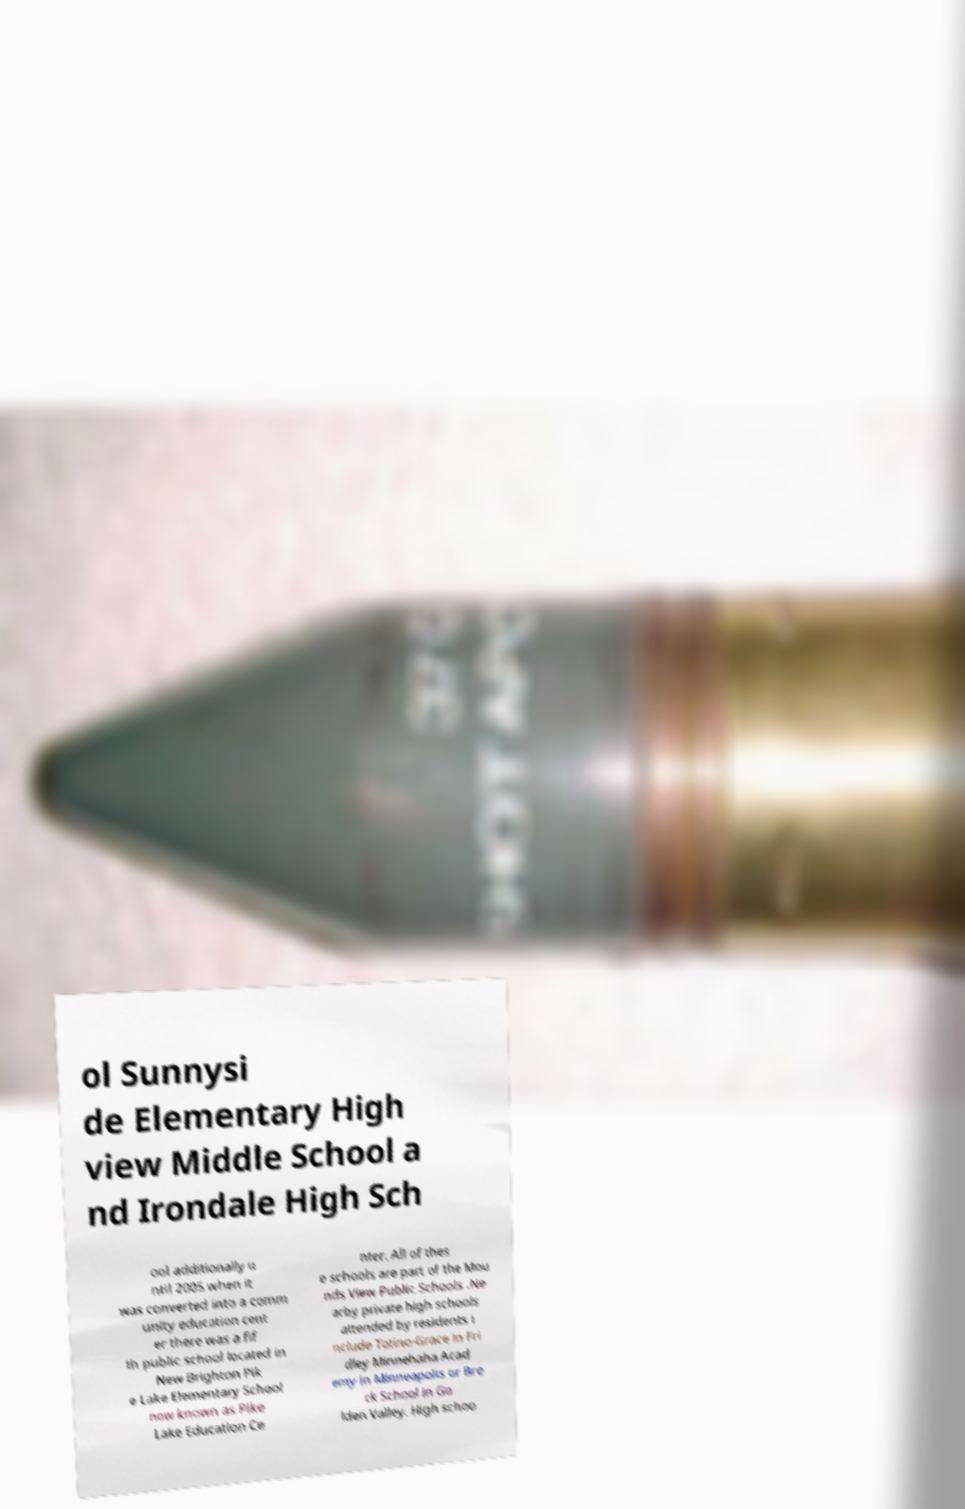Could you extract and type out the text from this image? ol Sunnysi de Elementary High view Middle School a nd Irondale High Sch ool additionally u ntil 2005 when it was converted into a comm unity education cent er there was a fif th public school located in New Brighton Pik e Lake Elementary School now known as Pike Lake Education Ce nter. All of thes e schools are part of the Mou nds View Public Schools .Ne arby private high schools attended by residents i nclude Totino-Grace in Fri dley Minnehaha Acad emy in Minneapolis or Bre ck School in Go lden Valley. High schoo 